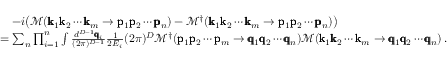Convert formula to latex. <formula><loc_0><loc_0><loc_500><loc_500>\begin{array} { r l } & { \quad - i \left ( \mathcal { M } ( \pm b { k } _ { 1 } \pm b { k } _ { 2 } \cdots \pm b { k } _ { m } \rightarrow \pm b { p } _ { 1 } \pm b { p } _ { 2 } \cdots \pm b { p } _ { n } ) - \mathcal { M } ^ { \dagger } ( \pm b { k } _ { 1 } \pm b { k } _ { 2 } \cdots \pm b { k } _ { m } \rightarrow \pm b { p } _ { 1 } \pm b { p } _ { 2 } \cdots \pm b { p } _ { n } ) \right ) } \\ & { = \sum _ { n } \prod _ { i = 1 } ^ { n } \int \frac { d ^ { D - 1 } \pm b { q } _ { i } } { ( 2 \pi ) ^ { D - 1 } } \frac { 1 } { 2 E _ { i } } ( 2 \pi ) ^ { D } \mathcal { M } ^ { \dagger } ( \pm b { p } _ { 1 } \pm b { p } _ { 2 } \cdots \pm b { p } _ { m } \rightarrow \pm b { q } _ { 1 } \pm b { q } _ { 2 } \cdots \pm b { q } _ { n } ) \mathcal { M } ( \pm b { k } _ { 1 } \pm b { k } _ { 2 } \cdots \pm b { k } _ { m } \rightarrow \pm b { q } _ { 1 } \pm b { q } _ { 2 } \cdots \pm b { q } _ { n } ) \, . } \end{array}</formula> 